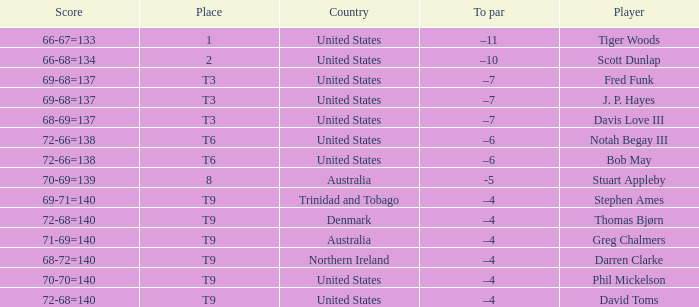What place did Bob May get when his score was 72-66=138? T6. 